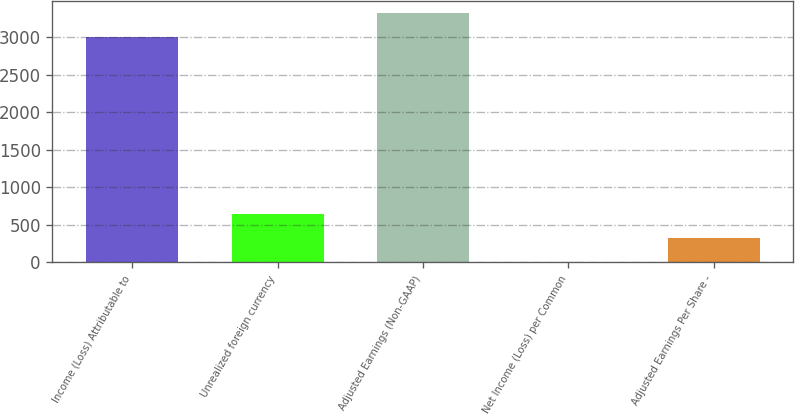Convert chart to OTSL. <chart><loc_0><loc_0><loc_500><loc_500><bar_chart><fcel>Income (Loss) Attributable to<fcel>Unrealized foreign currency<fcel>Adjusted Earnings (Non-GAAP)<fcel>Net Income (Loss) per Common<fcel>Adjusted Earnings Per Share -<nl><fcel>3000<fcel>641.16<fcel>3316.35<fcel>8.46<fcel>324.81<nl></chart> 